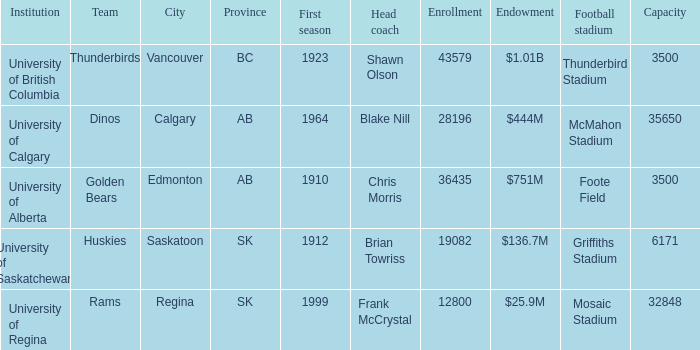How many grants does mosaic stadium possess? 1.0. 